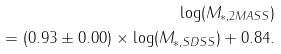Convert formula to latex. <formula><loc_0><loc_0><loc_500><loc_500>\log ( M _ { * , 2 M A S S } ) \\ = ( 0 . 9 3 \pm 0 . 0 0 ) \times \log ( M _ { * , S D S S } ) + 0 . 8 4 .</formula> 